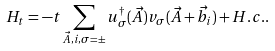Convert formula to latex. <formula><loc_0><loc_0><loc_500><loc_500>H _ { t } = - t \sum _ { \vec { A } , i , \sigma = \pm } u _ { \sigma } ^ { \dagger } ( \vec { A } ) v _ { \sigma } ( \vec { A } + \vec { b _ { i } } ) + H . c . .</formula> 